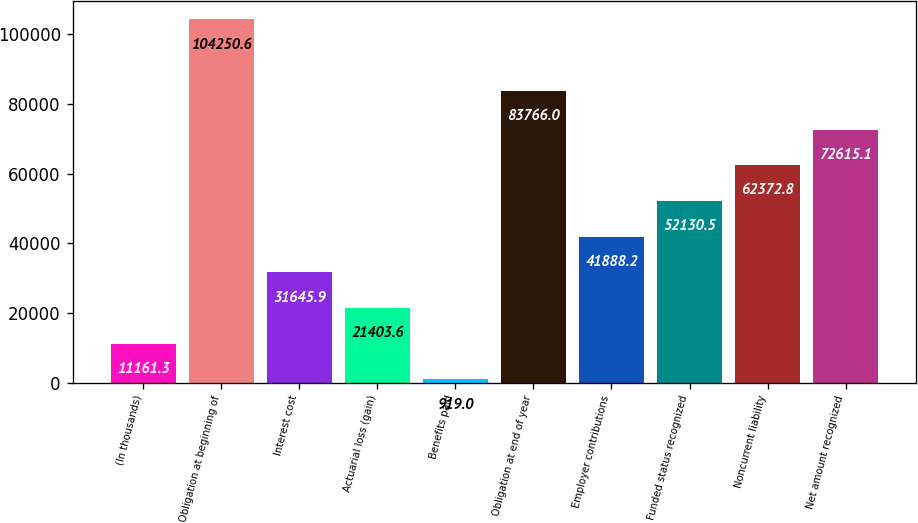<chart> <loc_0><loc_0><loc_500><loc_500><bar_chart><fcel>(In thousands)<fcel>Obligation at beginning of<fcel>Interest cost<fcel>Actuarial loss (gain)<fcel>Benefits paid<fcel>Obligation at end of year<fcel>Employer contributions<fcel>Funded status recognized<fcel>Noncurrent liability<fcel>Net amount recognized<nl><fcel>11161.3<fcel>104251<fcel>31645.9<fcel>21403.6<fcel>919<fcel>83766<fcel>41888.2<fcel>52130.5<fcel>62372.8<fcel>72615.1<nl></chart> 